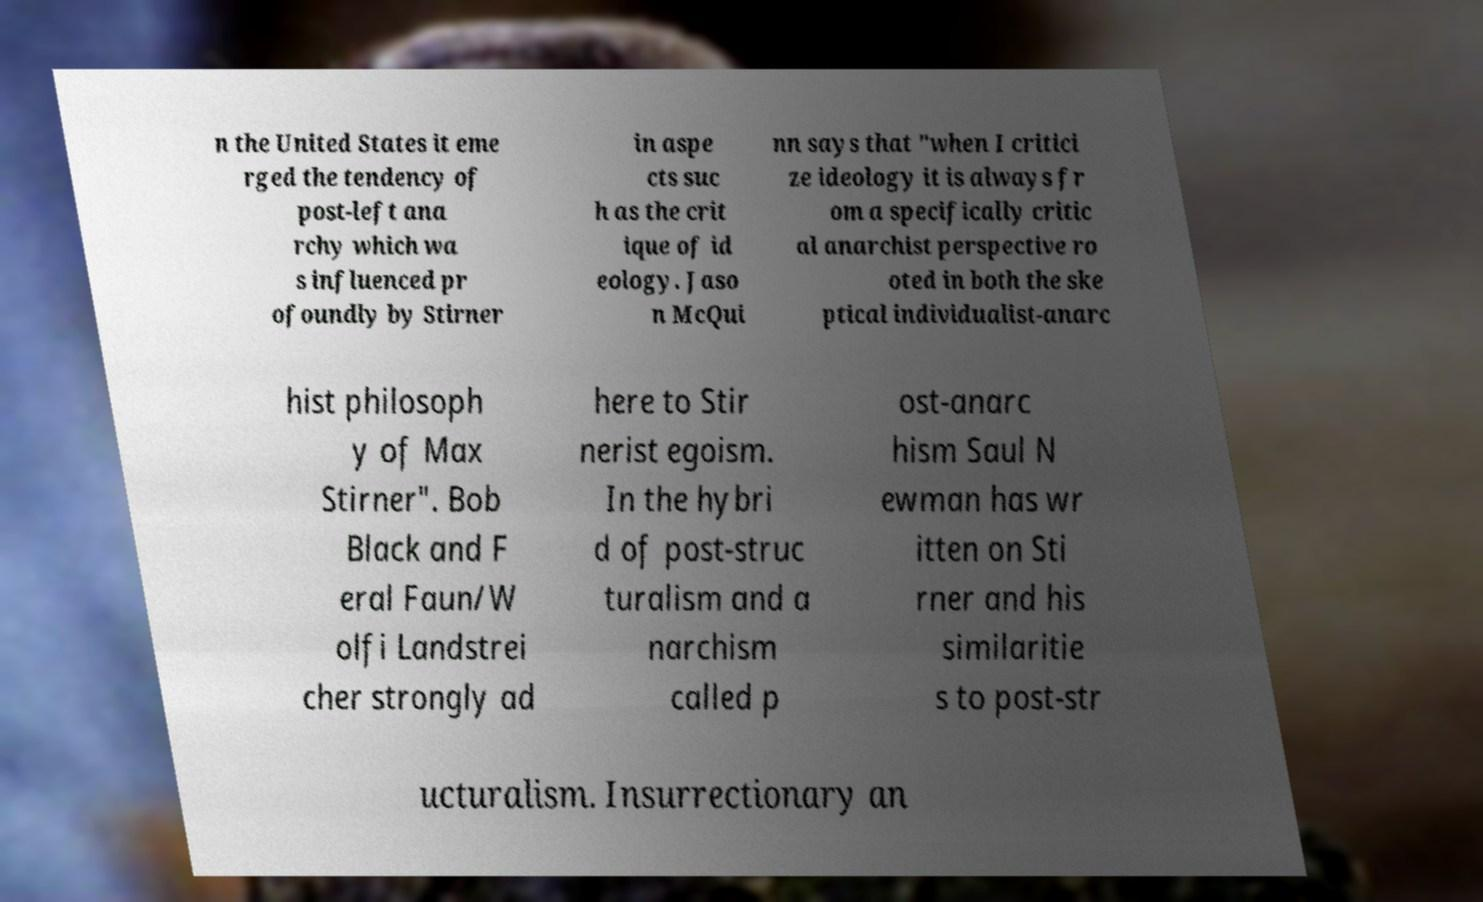Can you accurately transcribe the text from the provided image for me? n the United States it eme rged the tendency of post-left ana rchy which wa s influenced pr ofoundly by Stirner in aspe cts suc h as the crit ique of id eology. Jaso n McQui nn says that "when I critici ze ideology it is always fr om a specifically critic al anarchist perspective ro oted in both the ske ptical individualist-anarc hist philosoph y of Max Stirner". Bob Black and F eral Faun/W olfi Landstrei cher strongly ad here to Stir nerist egoism. In the hybri d of post-struc turalism and a narchism called p ost-anarc hism Saul N ewman has wr itten on Sti rner and his similaritie s to post-str ucturalism. Insurrectionary an 